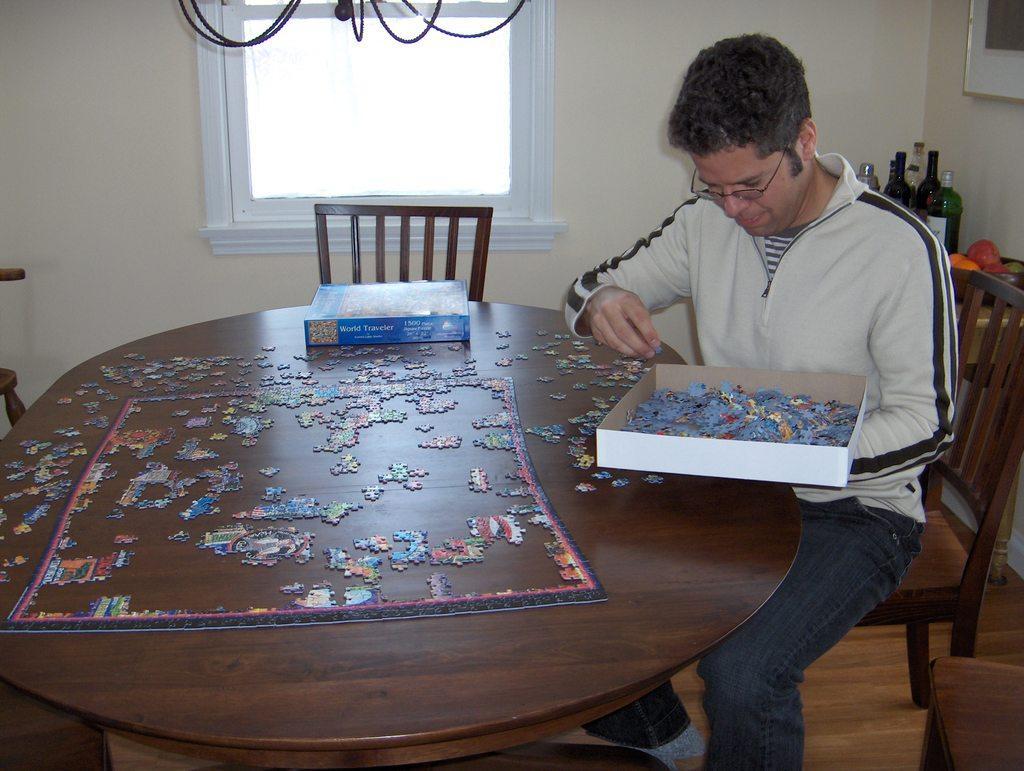Could you give a brief overview of what you see in this image? In this picture we can see man wore spectacle sitting on chair and holding box with legos in it and in front of him there is table and on table we can see some more legos and in background there is a window, bottle,fruits, wire. 